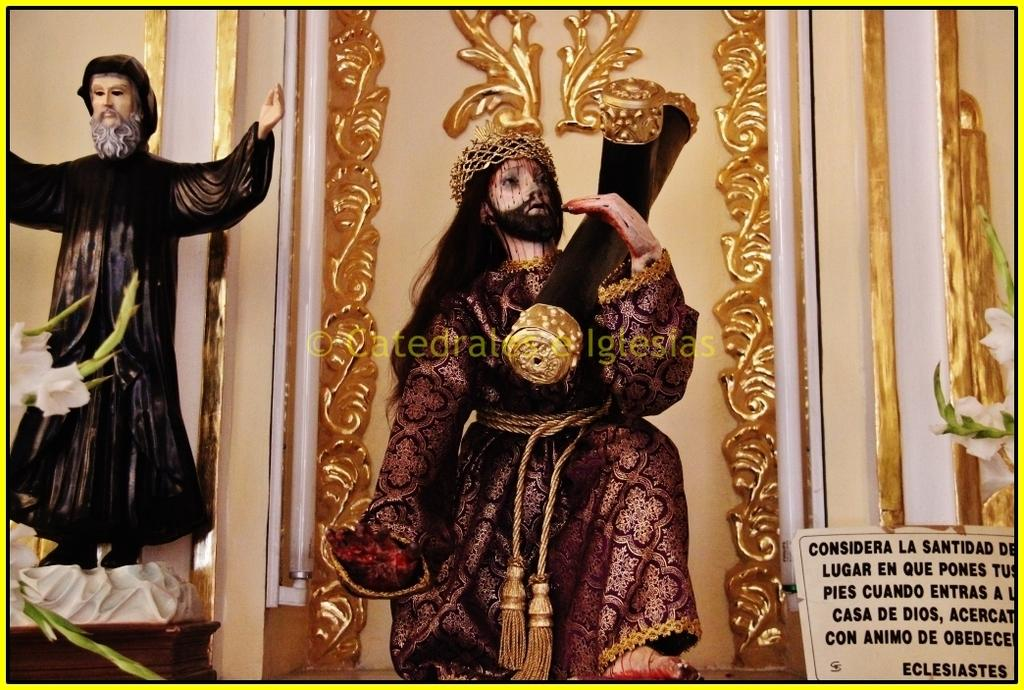What type of objects can be seen in the image? There are statues in the image. What is written or displayed on the board in the image? There is a board with text in the image. What kind of vegetation is present in the image? There are plants with flowers in the image. What type of vertical structures can be seen in the image? There are poles in the image. What type of barrier or boundary is visible in the image? There is a wall in the image. How many slaves are depicted in the image? There is no mention of slaves or any people in the image; it features statues, a board with text, plants with flowers, poles, and a wall. 